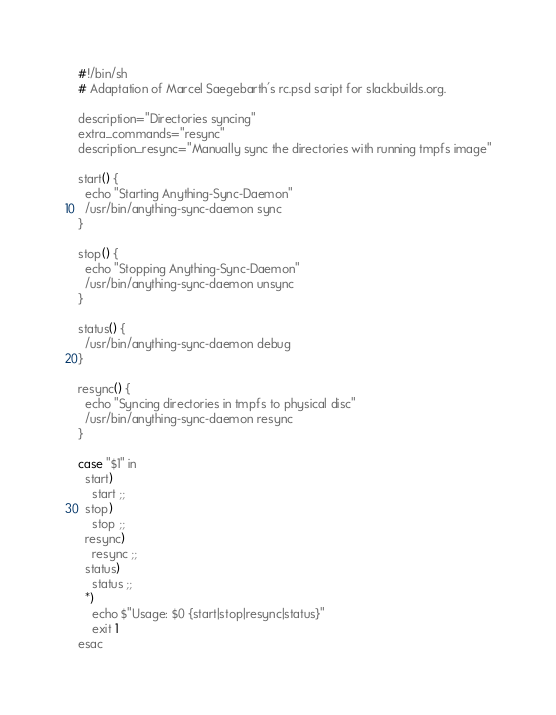Convert code to text. <code><loc_0><loc_0><loc_500><loc_500><_Lisp_>#!/bin/sh
# Adaptation of Marcel Saegebarth's rc.psd script for slackbuilds.org.

description="Directories syncing"
extra_commands="resync"
description_resync="Manually sync the directories with running tmpfs image"

start() {
  echo "Starting Anything-Sync-Daemon"
  /usr/bin/anything-sync-daemon sync
}

stop() {
  echo "Stopping Anything-Sync-Daemon"
  /usr/bin/anything-sync-daemon unsync
}

status() {
  /usr/bin/anything-sync-daemon debug
}

resync() {
  echo "Syncing directories in tmpfs to physical disc"
  /usr/bin/anything-sync-daemon resync
}

case "$1" in
  start)
    start ;;
  stop)
    stop ;;
  resync)
    resync ;;
  status)
    status ;;
  *)
    echo $"Usage: $0 {start|stop|resync|status}"
    exit 1
esac
</code> 